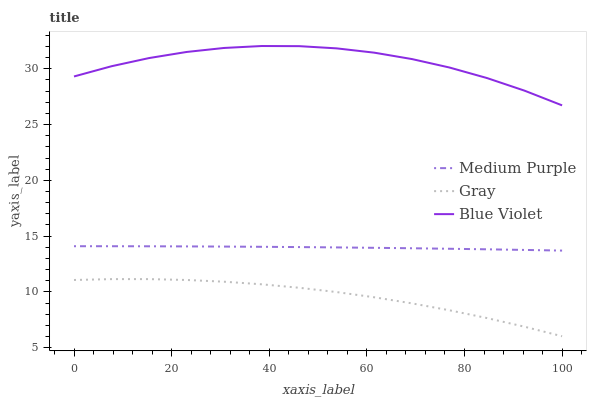Does Blue Violet have the minimum area under the curve?
Answer yes or no. No. Does Gray have the maximum area under the curve?
Answer yes or no. No. Is Gray the smoothest?
Answer yes or no. No. Is Gray the roughest?
Answer yes or no. No. Does Blue Violet have the lowest value?
Answer yes or no. No. Does Gray have the highest value?
Answer yes or no. No. Is Gray less than Blue Violet?
Answer yes or no. Yes. Is Blue Violet greater than Gray?
Answer yes or no. Yes. Does Gray intersect Blue Violet?
Answer yes or no. No. 